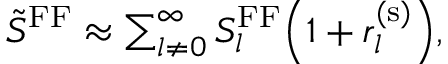<formula> <loc_0><loc_0><loc_500><loc_500>\begin{array} { r } { \tilde { S } ^ { F F } \approx \sum _ { l \neq 0 } ^ { \infty } S _ { l } ^ { F F } \left ( 1 + r _ { l } ^ { ( s ) } \right ) , } \end{array}</formula> 